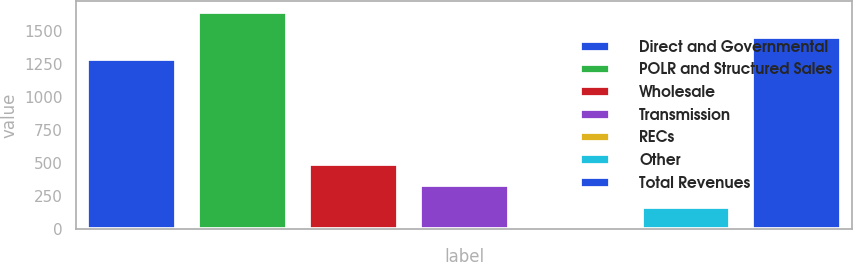Convert chart. <chart><loc_0><loc_0><loc_500><loc_500><bar_chart><fcel>Direct and Governmental<fcel>POLR and Structured Sales<fcel>Wholesale<fcel>Transmission<fcel>RECs<fcel>Other<fcel>Total Revenues<nl><fcel>1292<fcel>1645<fcel>498.4<fcel>334.6<fcel>7<fcel>170.8<fcel>1455.8<nl></chart> 